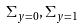<formula> <loc_0><loc_0><loc_500><loc_500>\Sigma _ { y = 0 } , \Sigma _ { y = 1 }</formula> 